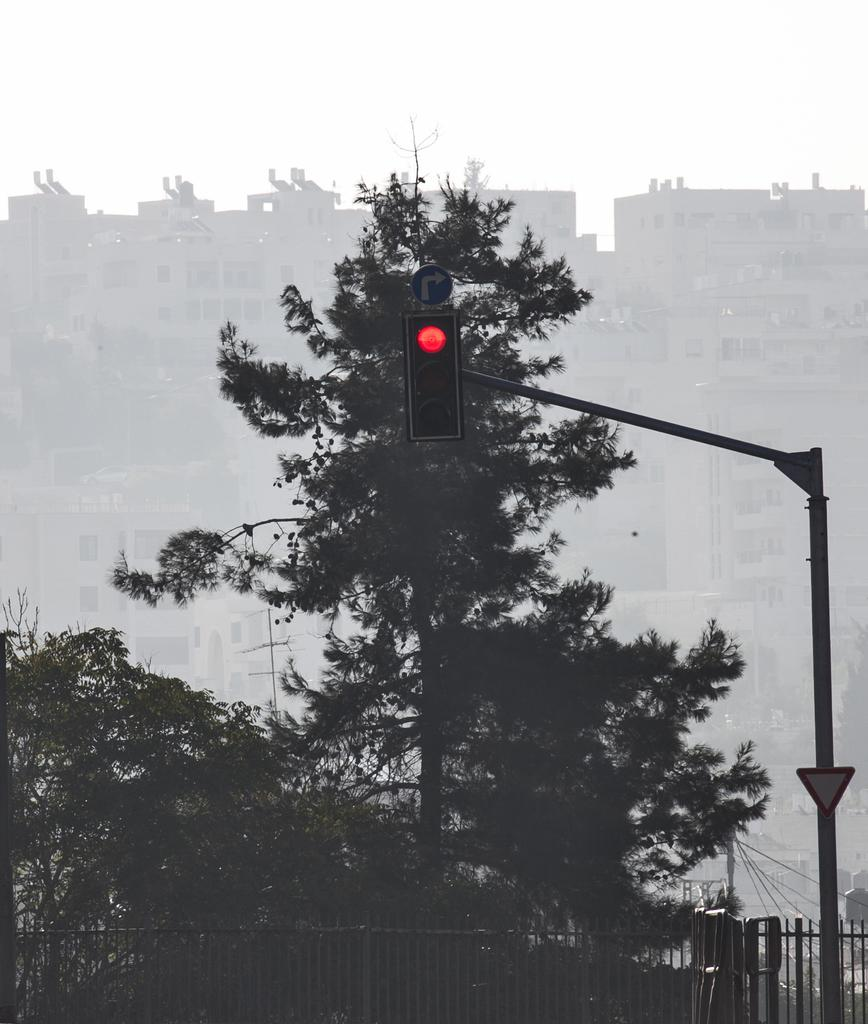What type of natural elements can be seen in the image? There are trees in the image. What type of man-made structures are present in the image? There are buildings in the image. What traffic control devices are visible in the image? There are traffic lights in the image. What type of informational signs are present in the image? There are sign boards in the image. What vertical structure can be seen in the image? There is a pole in the image. What type of barrier is present at the bottom of the image? There is a fence at the bottom of the image. Can you tell me where the doll is located in the image? There is no doll present in the image. What is the father doing in the image? There is no father present in the image. 